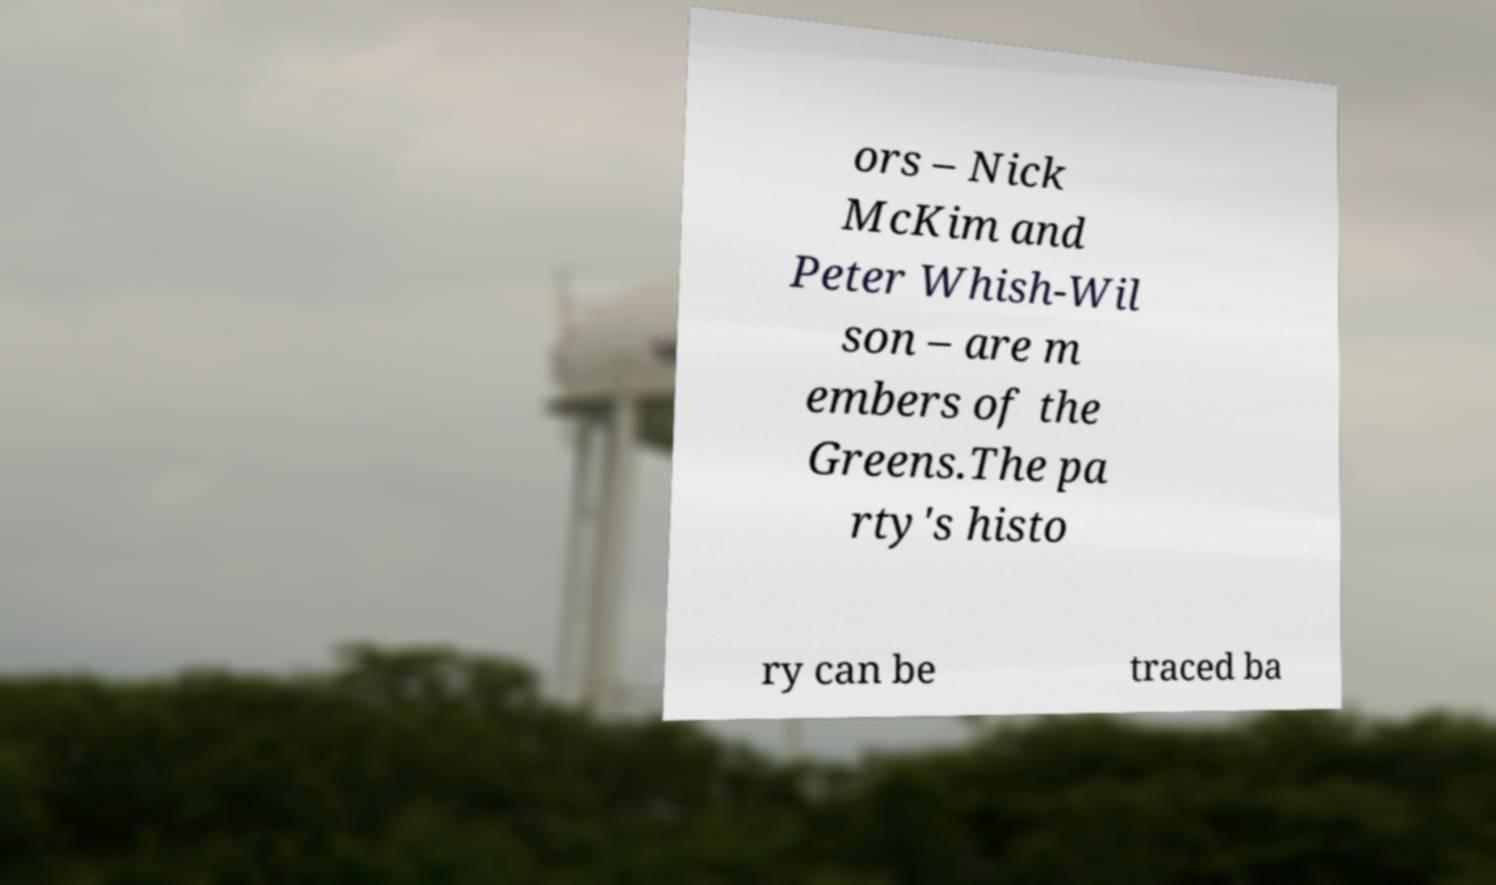Could you assist in decoding the text presented in this image and type it out clearly? ors – Nick McKim and Peter Whish-Wil son – are m embers of the Greens.The pa rty's histo ry can be traced ba 